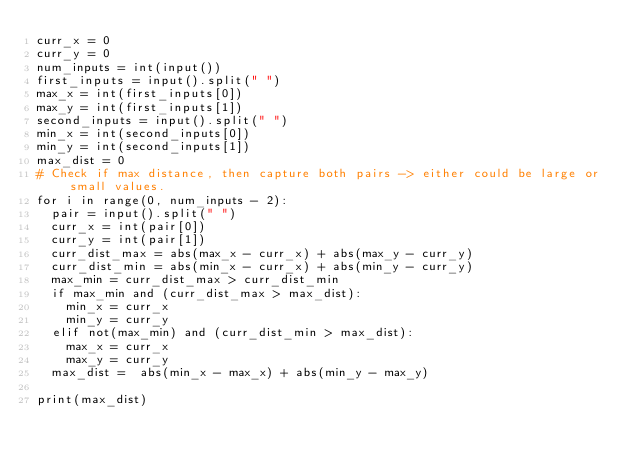<code> <loc_0><loc_0><loc_500><loc_500><_Python_>curr_x = 0
curr_y = 0
num_inputs = int(input())
first_inputs = input().split(" ")
max_x = int(first_inputs[0])
max_y = int(first_inputs[1])
second_inputs = input().split(" ")
min_x = int(second_inputs[0])
min_y = int(second_inputs[1])
max_dist = 0
# Check if max distance, then capture both pairs -> either could be large or small values.
for i in range(0, num_inputs - 2):
  pair = input().split(" ")
  curr_x = int(pair[0])
  curr_y = int(pair[1])
  curr_dist_max = abs(max_x - curr_x) + abs(max_y - curr_y)
  curr_dist_min = abs(min_x - curr_x) + abs(min_y - curr_y)
  max_min = curr_dist_max > curr_dist_min
  if max_min and (curr_dist_max > max_dist):
    min_x = curr_x
    min_y = curr_y
  elif not(max_min) and (curr_dist_min > max_dist):
    max_x = curr_x
    max_y = curr_y
  max_dist =  abs(min_x - max_x) + abs(min_y - max_y)

print(max_dist)</code> 